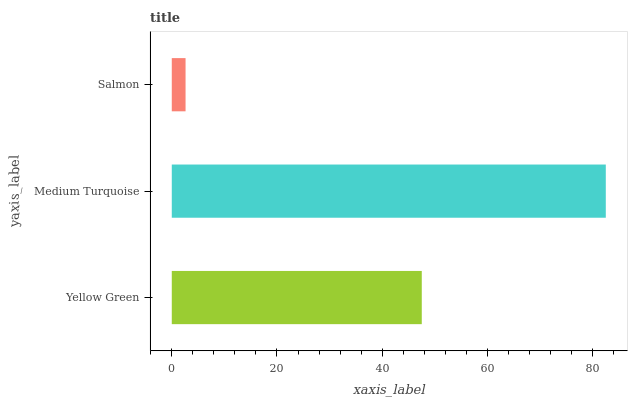Is Salmon the minimum?
Answer yes or no. Yes. Is Medium Turquoise the maximum?
Answer yes or no. Yes. Is Medium Turquoise the minimum?
Answer yes or no. No. Is Salmon the maximum?
Answer yes or no. No. Is Medium Turquoise greater than Salmon?
Answer yes or no. Yes. Is Salmon less than Medium Turquoise?
Answer yes or no. Yes. Is Salmon greater than Medium Turquoise?
Answer yes or no. No. Is Medium Turquoise less than Salmon?
Answer yes or no. No. Is Yellow Green the high median?
Answer yes or no. Yes. Is Yellow Green the low median?
Answer yes or no. Yes. Is Salmon the high median?
Answer yes or no. No. Is Salmon the low median?
Answer yes or no. No. 